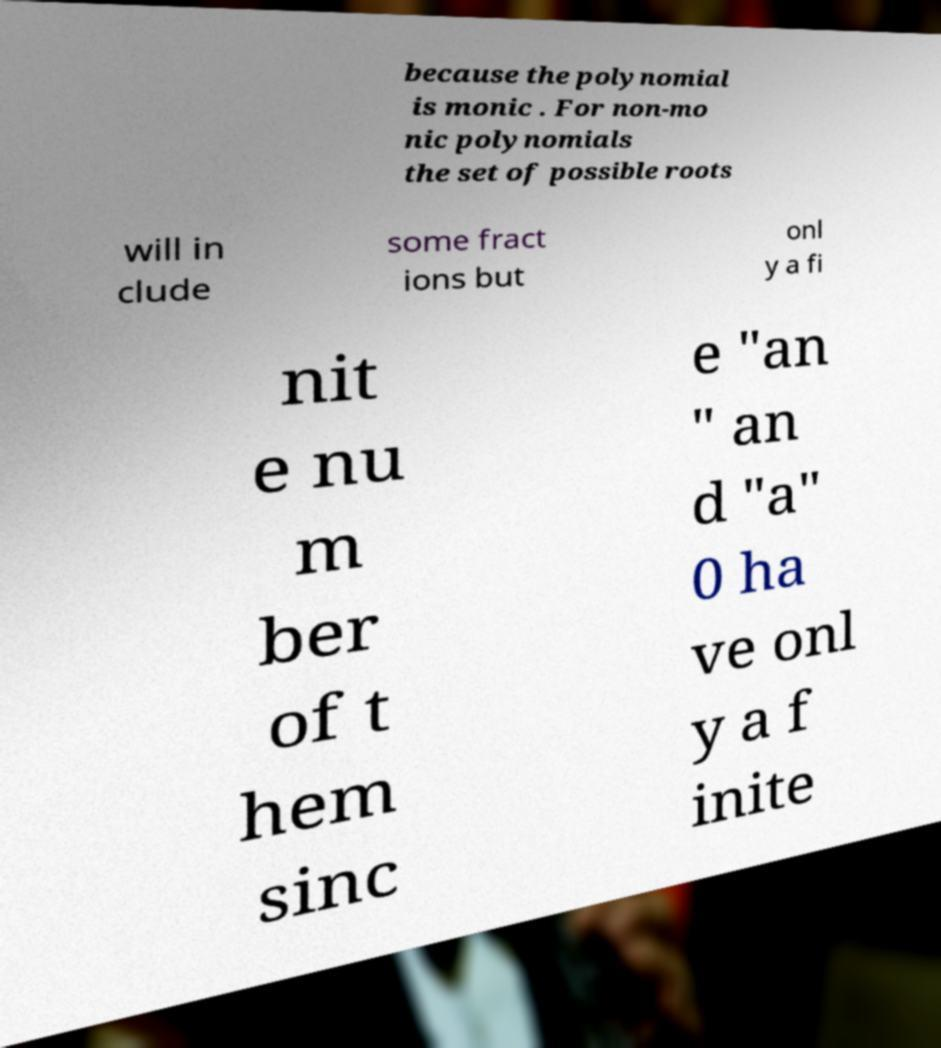Could you extract and type out the text from this image? because the polynomial is monic . For non-mo nic polynomials the set of possible roots will in clude some fract ions but onl y a fi nit e nu m ber of t hem sinc e "an " an d "a" 0 ha ve onl y a f inite 